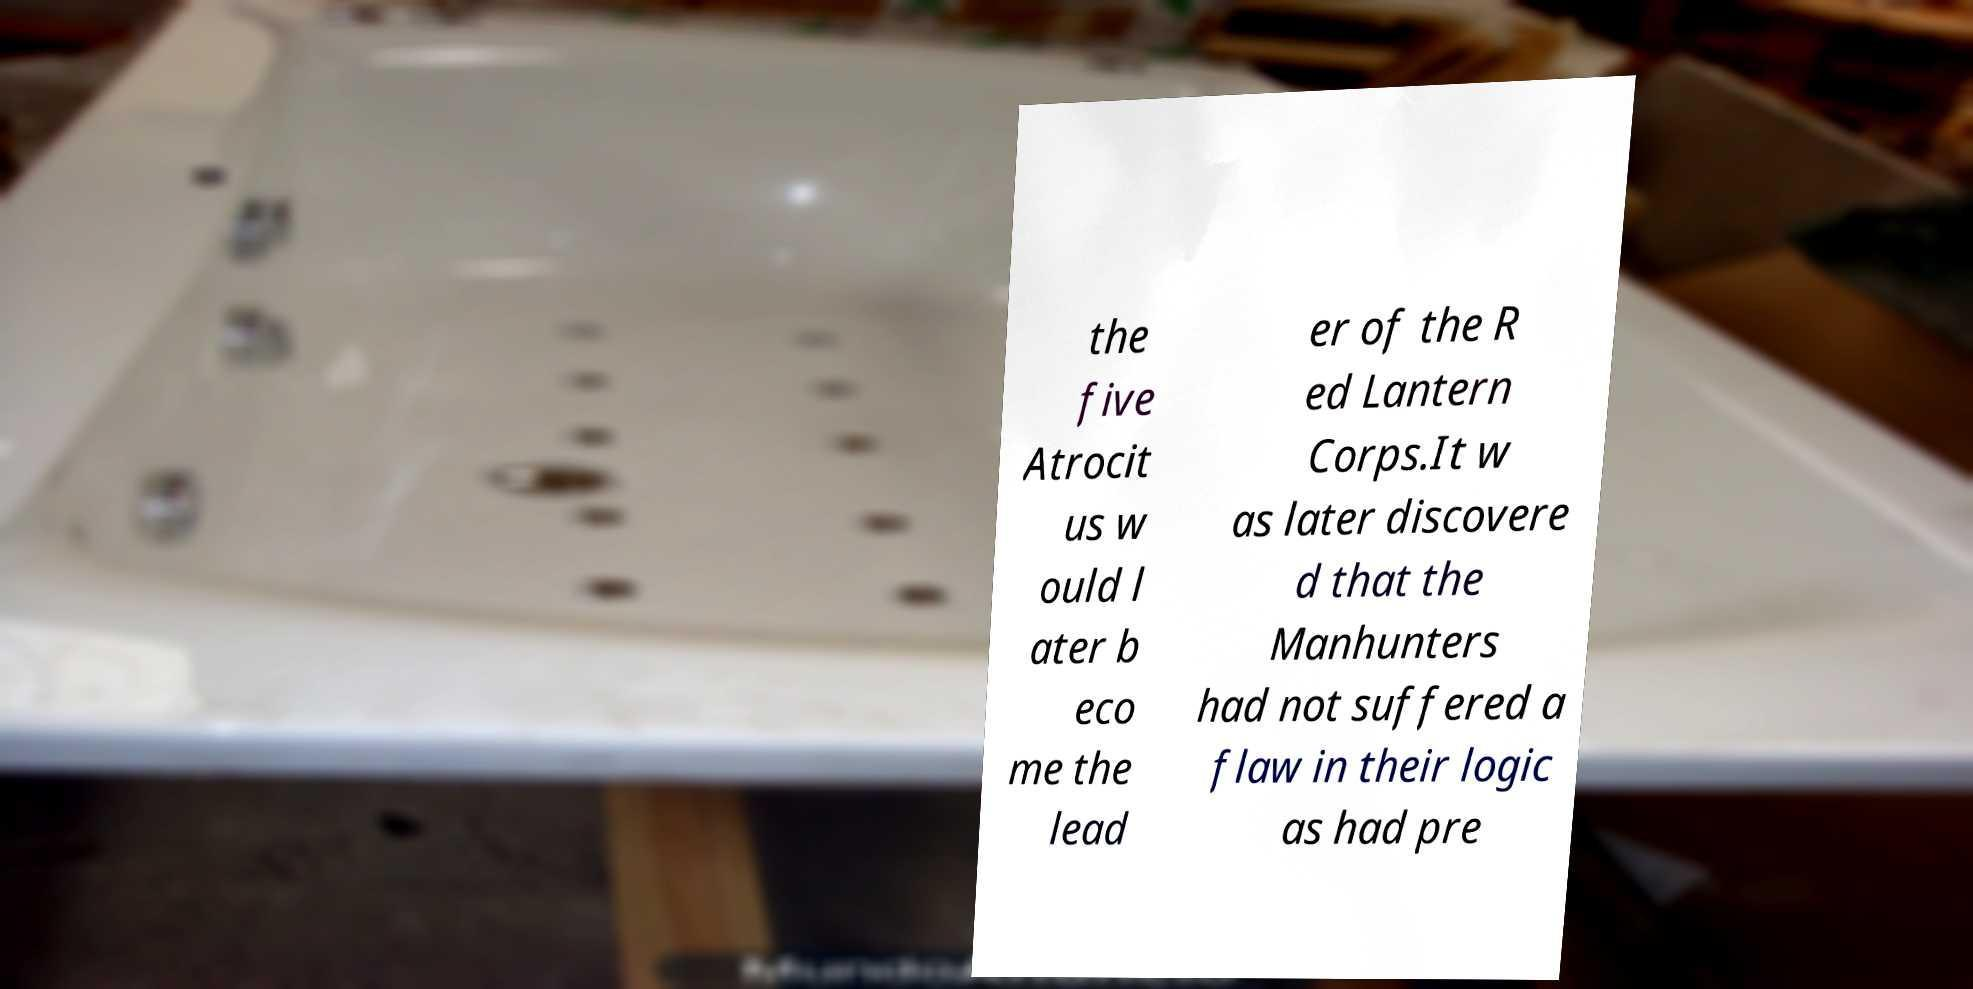Could you extract and type out the text from this image? the five Atrocit us w ould l ater b eco me the lead er of the R ed Lantern Corps.It w as later discovere d that the Manhunters had not suffered a flaw in their logic as had pre 